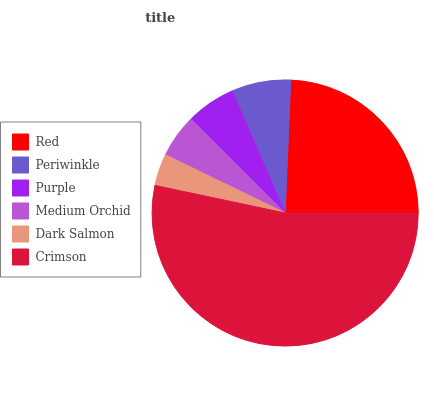Is Dark Salmon the minimum?
Answer yes or no. Yes. Is Crimson the maximum?
Answer yes or no. Yes. Is Periwinkle the minimum?
Answer yes or no. No. Is Periwinkle the maximum?
Answer yes or no. No. Is Red greater than Periwinkle?
Answer yes or no. Yes. Is Periwinkle less than Red?
Answer yes or no. Yes. Is Periwinkle greater than Red?
Answer yes or no. No. Is Red less than Periwinkle?
Answer yes or no. No. Is Periwinkle the high median?
Answer yes or no. Yes. Is Purple the low median?
Answer yes or no. Yes. Is Medium Orchid the high median?
Answer yes or no. No. Is Dark Salmon the low median?
Answer yes or no. No. 